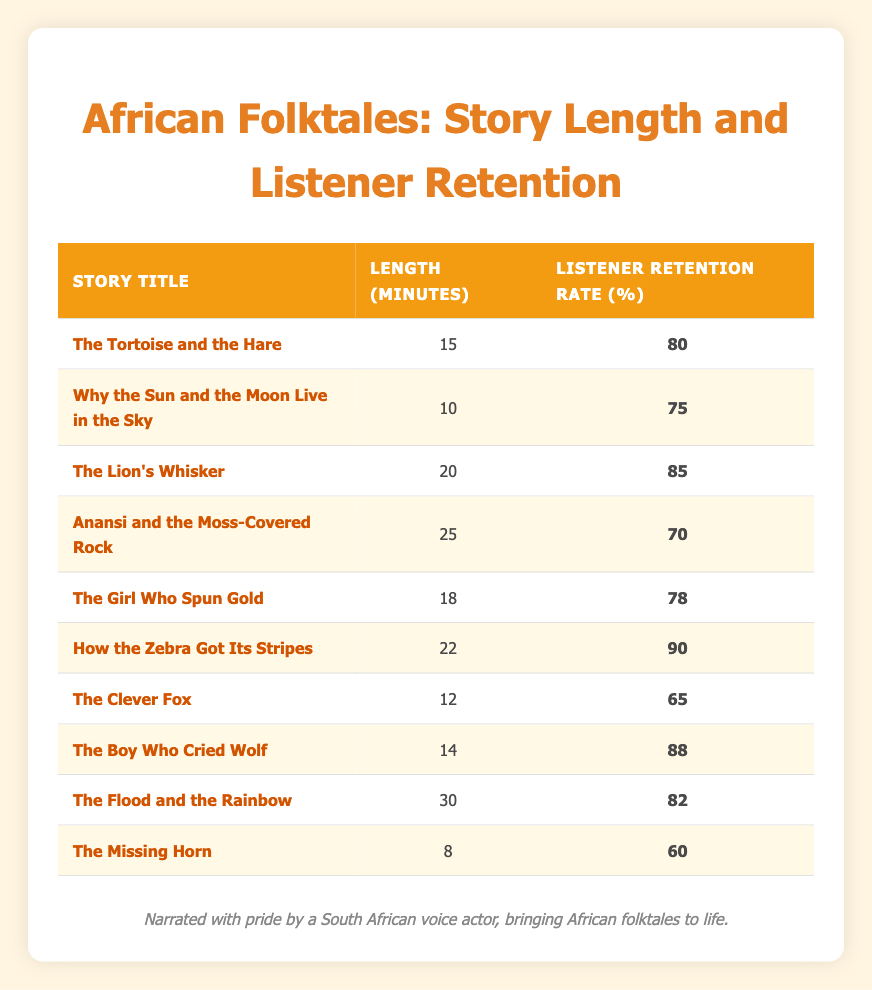What is the retention rate for "How the Zebra Got Its Stripes"? You can find "How the Zebra Got Its Stripes" in the table and check its associated listener retention rate, which is listed as 90 percent.
Answer: 90 Which story has the longest length and what is its retention rate? Looking through the lengths in the table, "The Flood and the Rainbow" has the longest length at 30 minutes, with a corresponding listener retention rate of 82 percent.
Answer: 82 How many stories have a listener retention rate above 80%? By examining the listener retention rates in the table, we find that the following stories have rates above 80%: "The Lion's Whisker" (85), "How the Zebra Got Its Stripes" (90), and "The Boy Who Cried Wolf" (88), totaling three stories above 80%.
Answer: 3 What is the average story length of all the stories listed? To find the average length, sum all the lengths: 15 + 10 + 20 + 25 + 18 + 22 + 12 + 14 + 30 + 8 =  180 minutes. Then divide by the number of stories (10): 180/10 = 18 minutes, giving the average length of 18 minutes.
Answer: 18 Is the listener retention rate for "The Clever Fox" greater than or equal to 70%? Checking the table, "The Clever Fox" has a retention rate of 65%, which is less than 70%, thus the statement is false.
Answer: No Which story has the highest retention rate and what is its length? "How the Zebra Got Its Stripes" has the highest retention rate at 90%. Its length, as listed in the table, is 22 minutes.
Answer: 22 minutes If we compare the average retention rates of stories longer than 20 minutes and those shorter than 20 minutes, which group has a higher average? The longer stories with lengths longer than 20 minutes are: "Anansi and the Moss-Covered Rock" (70), "How the Zebra Got Its Stripes" (90), and "The Flood and the Rainbow" (82). Their average is (70 + 90 + 82) / 3 = 80.67%. The shorter ones are: "The Tortoise and the Hare" (80), "Why the Sun and the Moon Live in the Sky" (75), "The Lion's Whisker" (85), "The Girl Who Spun Gold" (78), "The Clever Fox" (65), "The Boy Who Cried Wolf" (88), and "The Missing Horn" (60). Their average is (80 + 75 + 85 + 78 + 65 + 88 + 60) / 7 = 74.29%. Thus, stories longer than 20 minutes have a higher average retention rate.
Answer: Longer stories have a higher retention rate How much longer is "The Lion's Whisker" compared to "The Missing Horn"? "The Lion's Whisker" is 20 minutes long while "The Missing Horn" is 8 minutes, making it 20 - 8 = 12 minutes longer.
Answer: 12 minutes longer 